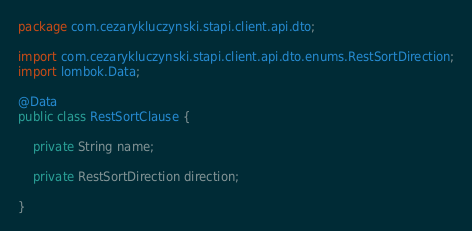Convert code to text. <code><loc_0><loc_0><loc_500><loc_500><_Java_>package com.cezarykluczynski.stapi.client.api.dto;

import com.cezarykluczynski.stapi.client.api.dto.enums.RestSortDirection;
import lombok.Data;

@Data
public class RestSortClause {

	private String name;

	private RestSortDirection direction;

}
</code> 